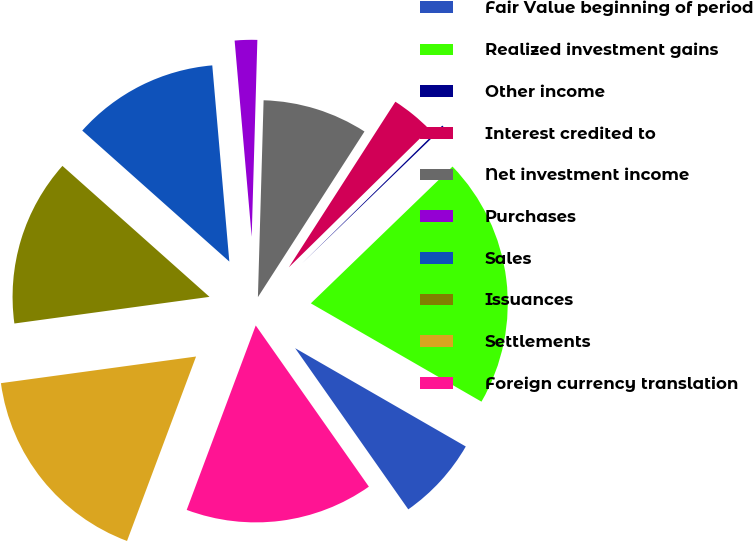Convert chart to OTSL. <chart><loc_0><loc_0><loc_500><loc_500><pie_chart><fcel>Fair Value beginning of period<fcel>Realized investment gains<fcel>Other income<fcel>Interest credited to<fcel>Net investment income<fcel>Purchases<fcel>Sales<fcel>Issuances<fcel>Settlements<fcel>Foreign currency translation<nl><fcel>6.94%<fcel>20.54%<fcel>0.14%<fcel>3.54%<fcel>8.64%<fcel>1.84%<fcel>12.04%<fcel>13.74%<fcel>17.14%<fcel>15.44%<nl></chart> 